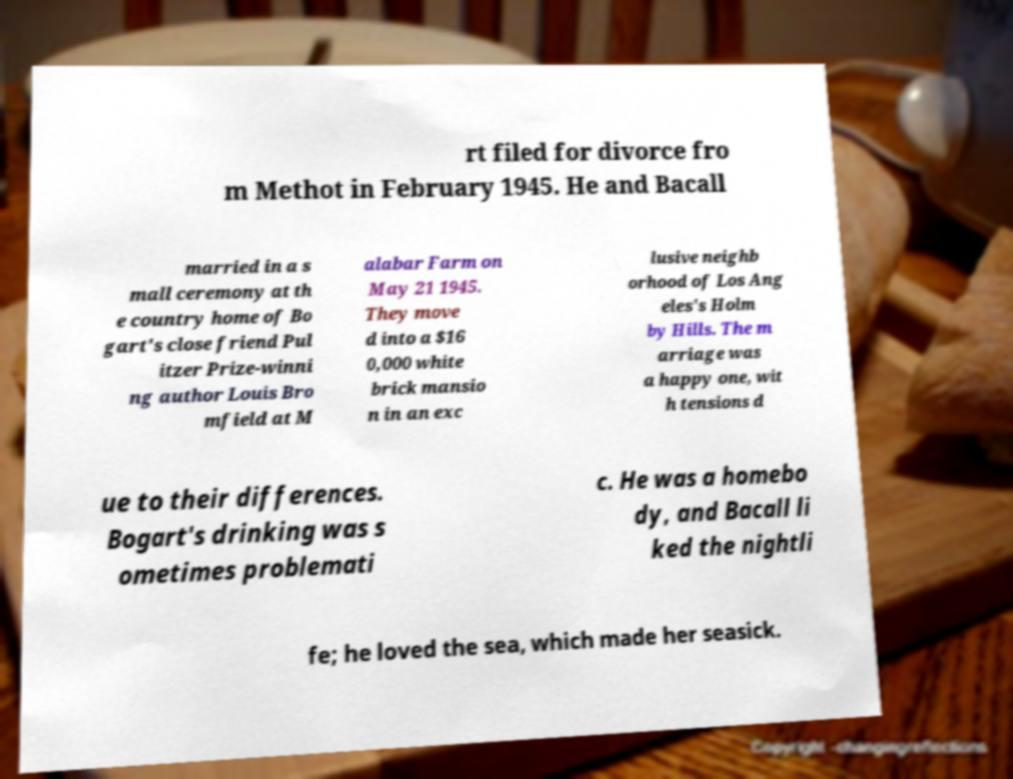Can you read and provide the text displayed in the image?This photo seems to have some interesting text. Can you extract and type it out for me? rt filed for divorce fro m Methot in February 1945. He and Bacall married in a s mall ceremony at th e country home of Bo gart's close friend Pul itzer Prize-winni ng author Louis Bro mfield at M alabar Farm on May 21 1945. They move d into a $16 0,000 white brick mansio n in an exc lusive neighb orhood of Los Ang eles's Holm by Hills. The m arriage was a happy one, wit h tensions d ue to their differences. Bogart's drinking was s ometimes problemati c. He was a homebo dy, and Bacall li ked the nightli fe; he loved the sea, which made her seasick. 